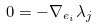Convert formula to latex. <formula><loc_0><loc_0><loc_500><loc_500>0 = - \nabla _ { e _ { i } } \lambda _ { j }</formula> 